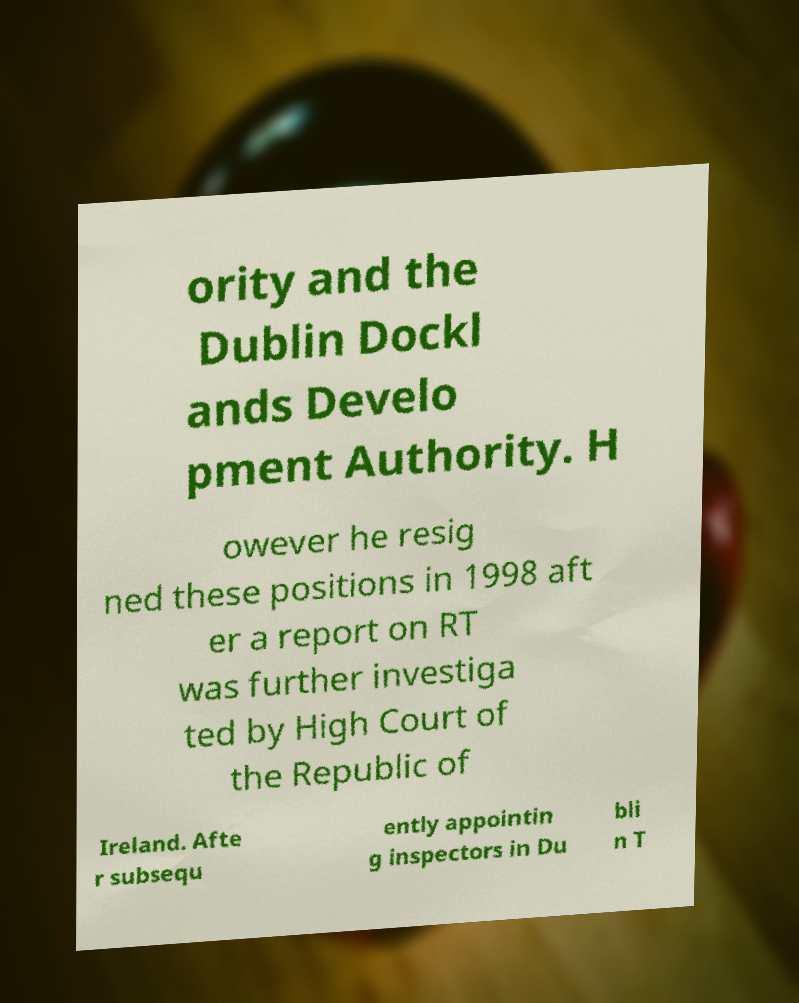There's text embedded in this image that I need extracted. Can you transcribe it verbatim? ority and the Dublin Dockl ands Develo pment Authority. H owever he resig ned these positions in 1998 aft er a report on RT was further investiga ted by High Court of the Republic of Ireland. Afte r subsequ ently appointin g inspectors in Du bli n T 